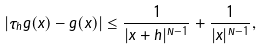<formula> <loc_0><loc_0><loc_500><loc_500>| \tau _ { h } g ( x ) - g ( x ) | \leq \frac { 1 } { | x + h | ^ { N - 1 } } + \frac { 1 } { | x | ^ { N - 1 } } ,</formula> 